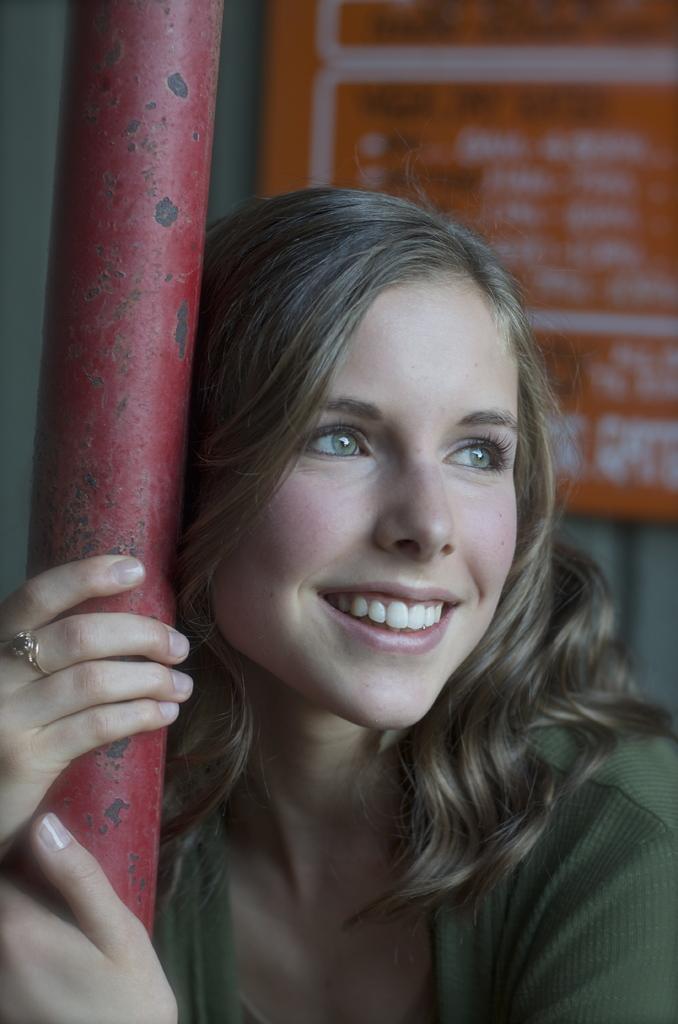Can you describe this image briefly? In the background we can see a board. In this picture we can see a woman holding a red pole with her hands. We can see a ring to her finger. 